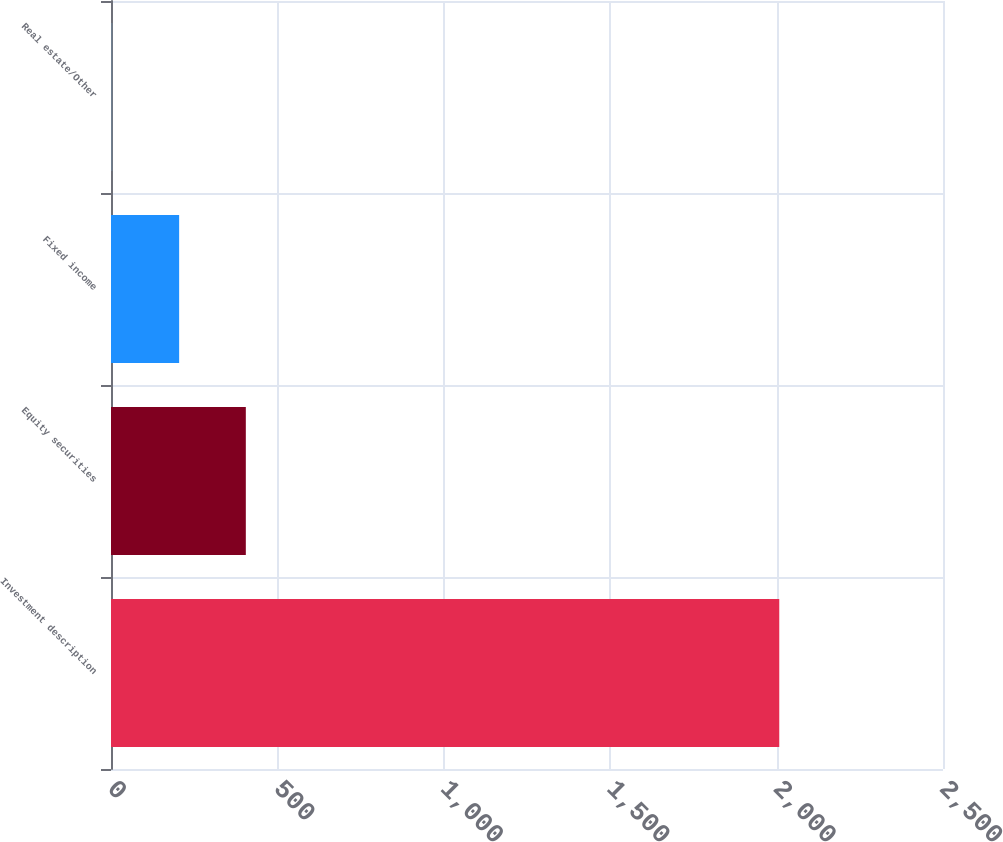<chart> <loc_0><loc_0><loc_500><loc_500><bar_chart><fcel>Investment description<fcel>Equity securities<fcel>Fixed income<fcel>Real estate/Other<nl><fcel>2008<fcel>405.12<fcel>204.76<fcel>4.4<nl></chart> 